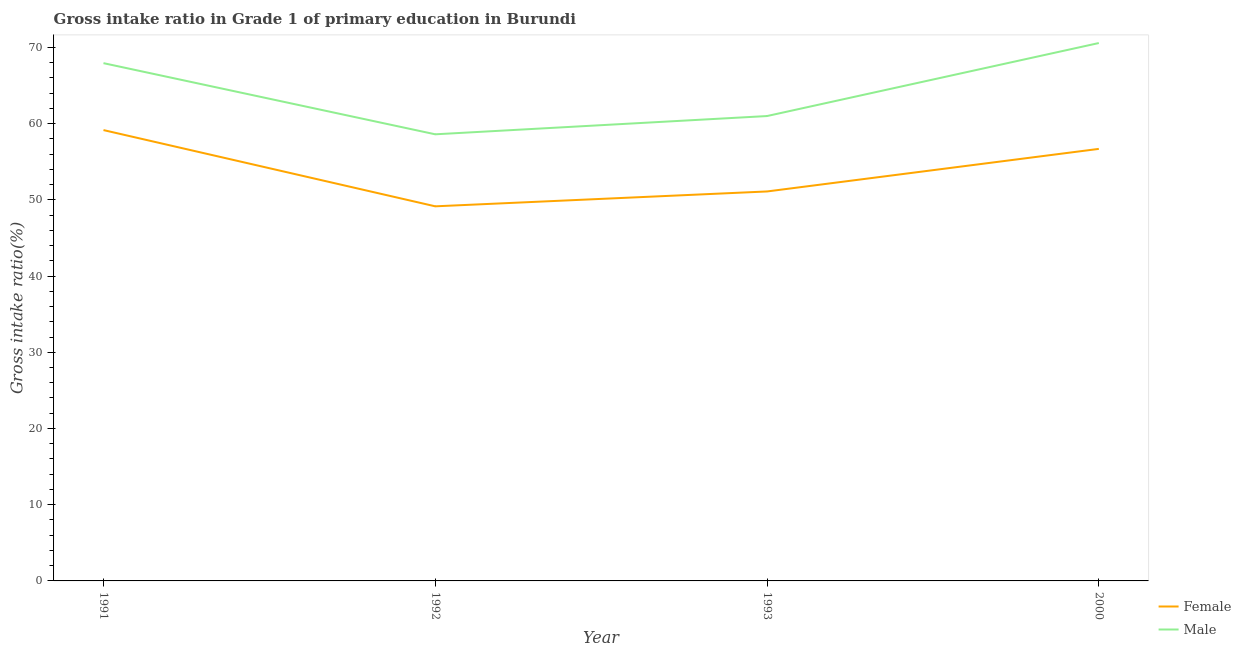What is the gross intake ratio(male) in 1993?
Provide a short and direct response. 60.99. Across all years, what is the maximum gross intake ratio(female)?
Ensure brevity in your answer.  59.15. Across all years, what is the minimum gross intake ratio(male)?
Provide a succinct answer. 58.59. In which year was the gross intake ratio(male) maximum?
Give a very brief answer. 2000. In which year was the gross intake ratio(male) minimum?
Ensure brevity in your answer.  1992. What is the total gross intake ratio(female) in the graph?
Offer a terse response. 216.07. What is the difference between the gross intake ratio(female) in 1992 and that in 2000?
Provide a short and direct response. -7.53. What is the difference between the gross intake ratio(male) in 1993 and the gross intake ratio(female) in 1992?
Your answer should be compact. 11.84. What is the average gross intake ratio(male) per year?
Ensure brevity in your answer.  64.52. In the year 1992, what is the difference between the gross intake ratio(female) and gross intake ratio(male)?
Give a very brief answer. -9.45. What is the ratio of the gross intake ratio(male) in 1991 to that in 1993?
Offer a terse response. 1.11. Is the difference between the gross intake ratio(male) in 1992 and 1993 greater than the difference between the gross intake ratio(female) in 1992 and 1993?
Your answer should be very brief. No. What is the difference between the highest and the second highest gross intake ratio(male)?
Keep it short and to the point. 2.64. What is the difference between the highest and the lowest gross intake ratio(male)?
Provide a short and direct response. 11.97. In how many years, is the gross intake ratio(male) greater than the average gross intake ratio(male) taken over all years?
Provide a succinct answer. 2. Is the sum of the gross intake ratio(male) in 1991 and 2000 greater than the maximum gross intake ratio(female) across all years?
Provide a short and direct response. Yes. How many lines are there?
Your answer should be very brief. 2. How many years are there in the graph?
Provide a short and direct response. 4. What is the difference between two consecutive major ticks on the Y-axis?
Your response must be concise. 10. Are the values on the major ticks of Y-axis written in scientific E-notation?
Your answer should be very brief. No. Does the graph contain any zero values?
Ensure brevity in your answer.  No. Does the graph contain grids?
Offer a terse response. No. What is the title of the graph?
Your response must be concise. Gross intake ratio in Grade 1 of primary education in Burundi. Does "Primary education" appear as one of the legend labels in the graph?
Your answer should be very brief. No. What is the label or title of the Y-axis?
Your answer should be very brief. Gross intake ratio(%). What is the Gross intake ratio(%) of Female in 1991?
Keep it short and to the point. 59.15. What is the Gross intake ratio(%) in Male in 1991?
Offer a very short reply. 67.93. What is the Gross intake ratio(%) in Female in 1992?
Offer a terse response. 49.15. What is the Gross intake ratio(%) of Male in 1992?
Keep it short and to the point. 58.59. What is the Gross intake ratio(%) of Female in 1993?
Your response must be concise. 51.1. What is the Gross intake ratio(%) in Male in 1993?
Give a very brief answer. 60.99. What is the Gross intake ratio(%) in Female in 2000?
Provide a short and direct response. 56.68. What is the Gross intake ratio(%) in Male in 2000?
Ensure brevity in your answer.  70.57. Across all years, what is the maximum Gross intake ratio(%) of Female?
Offer a terse response. 59.15. Across all years, what is the maximum Gross intake ratio(%) of Male?
Keep it short and to the point. 70.57. Across all years, what is the minimum Gross intake ratio(%) in Female?
Offer a very short reply. 49.15. Across all years, what is the minimum Gross intake ratio(%) of Male?
Your response must be concise. 58.59. What is the total Gross intake ratio(%) of Female in the graph?
Provide a short and direct response. 216.07. What is the total Gross intake ratio(%) in Male in the graph?
Give a very brief answer. 258.08. What is the difference between the Gross intake ratio(%) in Female in 1991 and that in 1992?
Make the answer very short. 10. What is the difference between the Gross intake ratio(%) in Male in 1991 and that in 1992?
Your response must be concise. 9.33. What is the difference between the Gross intake ratio(%) of Female in 1991 and that in 1993?
Offer a terse response. 8.05. What is the difference between the Gross intake ratio(%) of Male in 1991 and that in 1993?
Ensure brevity in your answer.  6.94. What is the difference between the Gross intake ratio(%) in Female in 1991 and that in 2000?
Provide a short and direct response. 2.47. What is the difference between the Gross intake ratio(%) of Male in 1991 and that in 2000?
Provide a succinct answer. -2.64. What is the difference between the Gross intake ratio(%) in Female in 1992 and that in 1993?
Keep it short and to the point. -1.95. What is the difference between the Gross intake ratio(%) of Male in 1992 and that in 1993?
Offer a terse response. -2.4. What is the difference between the Gross intake ratio(%) of Female in 1992 and that in 2000?
Your answer should be compact. -7.53. What is the difference between the Gross intake ratio(%) in Male in 1992 and that in 2000?
Provide a short and direct response. -11.97. What is the difference between the Gross intake ratio(%) of Female in 1993 and that in 2000?
Your response must be concise. -5.59. What is the difference between the Gross intake ratio(%) of Male in 1993 and that in 2000?
Give a very brief answer. -9.58. What is the difference between the Gross intake ratio(%) in Female in 1991 and the Gross intake ratio(%) in Male in 1992?
Ensure brevity in your answer.  0.55. What is the difference between the Gross intake ratio(%) of Female in 1991 and the Gross intake ratio(%) of Male in 1993?
Provide a succinct answer. -1.84. What is the difference between the Gross intake ratio(%) in Female in 1991 and the Gross intake ratio(%) in Male in 2000?
Your answer should be compact. -11.42. What is the difference between the Gross intake ratio(%) of Female in 1992 and the Gross intake ratio(%) of Male in 1993?
Provide a short and direct response. -11.84. What is the difference between the Gross intake ratio(%) in Female in 1992 and the Gross intake ratio(%) in Male in 2000?
Your response must be concise. -21.42. What is the difference between the Gross intake ratio(%) in Female in 1993 and the Gross intake ratio(%) in Male in 2000?
Your answer should be very brief. -19.47. What is the average Gross intake ratio(%) in Female per year?
Your response must be concise. 54.02. What is the average Gross intake ratio(%) in Male per year?
Make the answer very short. 64.52. In the year 1991, what is the difference between the Gross intake ratio(%) of Female and Gross intake ratio(%) of Male?
Make the answer very short. -8.78. In the year 1992, what is the difference between the Gross intake ratio(%) of Female and Gross intake ratio(%) of Male?
Your answer should be compact. -9.45. In the year 1993, what is the difference between the Gross intake ratio(%) in Female and Gross intake ratio(%) in Male?
Your answer should be compact. -9.89. In the year 2000, what is the difference between the Gross intake ratio(%) of Female and Gross intake ratio(%) of Male?
Your response must be concise. -13.89. What is the ratio of the Gross intake ratio(%) of Female in 1991 to that in 1992?
Your answer should be very brief. 1.2. What is the ratio of the Gross intake ratio(%) in Male in 1991 to that in 1992?
Ensure brevity in your answer.  1.16. What is the ratio of the Gross intake ratio(%) in Female in 1991 to that in 1993?
Provide a succinct answer. 1.16. What is the ratio of the Gross intake ratio(%) in Male in 1991 to that in 1993?
Your answer should be compact. 1.11. What is the ratio of the Gross intake ratio(%) in Female in 1991 to that in 2000?
Provide a succinct answer. 1.04. What is the ratio of the Gross intake ratio(%) in Male in 1991 to that in 2000?
Keep it short and to the point. 0.96. What is the ratio of the Gross intake ratio(%) in Female in 1992 to that in 1993?
Ensure brevity in your answer.  0.96. What is the ratio of the Gross intake ratio(%) of Male in 1992 to that in 1993?
Your answer should be very brief. 0.96. What is the ratio of the Gross intake ratio(%) of Female in 1992 to that in 2000?
Offer a very short reply. 0.87. What is the ratio of the Gross intake ratio(%) in Male in 1992 to that in 2000?
Your answer should be compact. 0.83. What is the ratio of the Gross intake ratio(%) in Female in 1993 to that in 2000?
Your answer should be very brief. 0.9. What is the ratio of the Gross intake ratio(%) in Male in 1993 to that in 2000?
Make the answer very short. 0.86. What is the difference between the highest and the second highest Gross intake ratio(%) of Female?
Ensure brevity in your answer.  2.47. What is the difference between the highest and the second highest Gross intake ratio(%) of Male?
Your answer should be compact. 2.64. What is the difference between the highest and the lowest Gross intake ratio(%) in Female?
Your answer should be compact. 10. What is the difference between the highest and the lowest Gross intake ratio(%) of Male?
Keep it short and to the point. 11.97. 